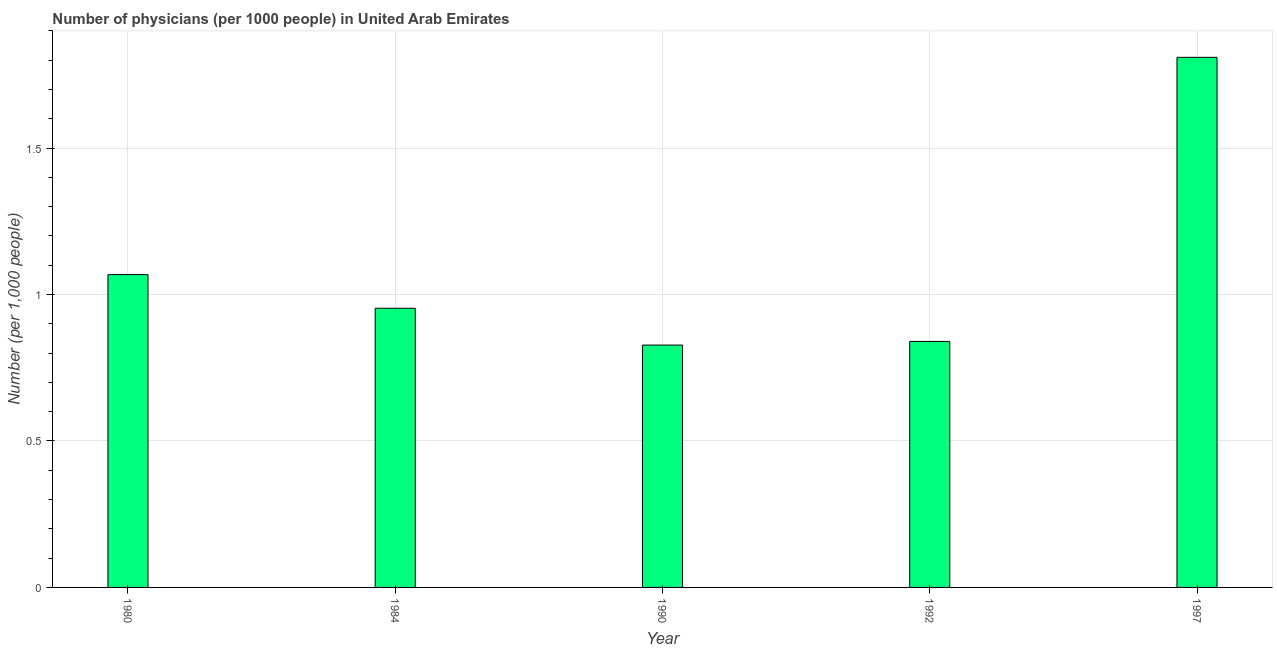What is the title of the graph?
Make the answer very short. Number of physicians (per 1000 people) in United Arab Emirates. What is the label or title of the X-axis?
Offer a very short reply. Year. What is the label or title of the Y-axis?
Offer a very short reply. Number (per 1,0 people). What is the number of physicians in 1984?
Your answer should be compact. 0.95. Across all years, what is the maximum number of physicians?
Provide a succinct answer. 1.81. Across all years, what is the minimum number of physicians?
Offer a very short reply. 0.83. In which year was the number of physicians maximum?
Your response must be concise. 1997. What is the sum of the number of physicians?
Ensure brevity in your answer.  5.5. What is the difference between the number of physicians in 1980 and 1990?
Your answer should be very brief. 0.24. What is the average number of physicians per year?
Provide a short and direct response. 1.1. What is the median number of physicians?
Your answer should be compact. 0.95. In how many years, is the number of physicians greater than 1 ?
Your response must be concise. 2. Do a majority of the years between 1997 and 1980 (inclusive) have number of physicians greater than 1.8 ?
Your answer should be compact. Yes. What is the ratio of the number of physicians in 1980 to that in 1997?
Provide a short and direct response. 0.59. Is the number of physicians in 1990 less than that in 1992?
Make the answer very short. Yes. What is the difference between the highest and the second highest number of physicians?
Your answer should be compact. 0.74. Is the sum of the number of physicians in 1980 and 1984 greater than the maximum number of physicians across all years?
Make the answer very short. Yes. In how many years, is the number of physicians greater than the average number of physicians taken over all years?
Your response must be concise. 1. How many years are there in the graph?
Ensure brevity in your answer.  5. What is the Number (per 1,000 people) in 1980?
Keep it short and to the point. 1.07. What is the Number (per 1,000 people) in 1984?
Provide a short and direct response. 0.95. What is the Number (per 1,000 people) in 1990?
Provide a short and direct response. 0.83. What is the Number (per 1,000 people) in 1992?
Your response must be concise. 0.84. What is the Number (per 1,000 people) of 1997?
Offer a very short reply. 1.81. What is the difference between the Number (per 1,000 people) in 1980 and 1984?
Provide a short and direct response. 0.11. What is the difference between the Number (per 1,000 people) in 1980 and 1990?
Provide a short and direct response. 0.24. What is the difference between the Number (per 1,000 people) in 1980 and 1992?
Make the answer very short. 0.23. What is the difference between the Number (per 1,000 people) in 1980 and 1997?
Offer a terse response. -0.74. What is the difference between the Number (per 1,000 people) in 1984 and 1990?
Offer a terse response. 0.13. What is the difference between the Number (per 1,000 people) in 1984 and 1992?
Your response must be concise. 0.11. What is the difference between the Number (per 1,000 people) in 1984 and 1997?
Ensure brevity in your answer.  -0.86. What is the difference between the Number (per 1,000 people) in 1990 and 1992?
Your response must be concise. -0.01. What is the difference between the Number (per 1,000 people) in 1990 and 1997?
Give a very brief answer. -0.98. What is the difference between the Number (per 1,000 people) in 1992 and 1997?
Your response must be concise. -0.97. What is the ratio of the Number (per 1,000 people) in 1980 to that in 1984?
Provide a succinct answer. 1.12. What is the ratio of the Number (per 1,000 people) in 1980 to that in 1990?
Your response must be concise. 1.29. What is the ratio of the Number (per 1,000 people) in 1980 to that in 1992?
Offer a very short reply. 1.27. What is the ratio of the Number (per 1,000 people) in 1980 to that in 1997?
Keep it short and to the point. 0.59. What is the ratio of the Number (per 1,000 people) in 1984 to that in 1990?
Provide a succinct answer. 1.15. What is the ratio of the Number (per 1,000 people) in 1984 to that in 1992?
Offer a terse response. 1.14. What is the ratio of the Number (per 1,000 people) in 1984 to that in 1997?
Ensure brevity in your answer.  0.53. What is the ratio of the Number (per 1,000 people) in 1990 to that in 1992?
Give a very brief answer. 0.98. What is the ratio of the Number (per 1,000 people) in 1990 to that in 1997?
Provide a short and direct response. 0.46. What is the ratio of the Number (per 1,000 people) in 1992 to that in 1997?
Provide a short and direct response. 0.46. 